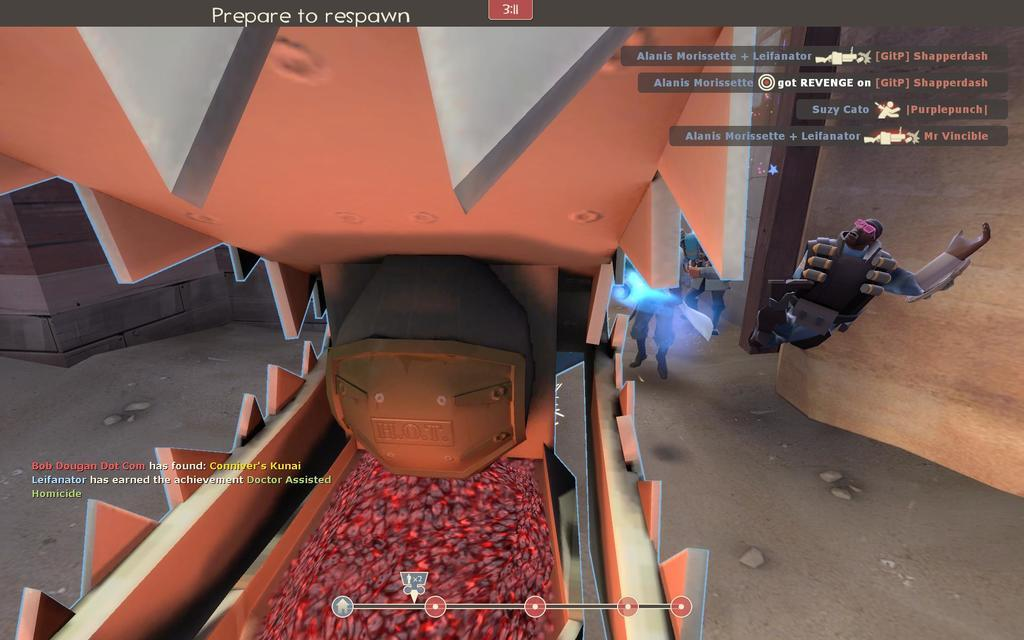What type of image is being described? The image appears to be animated. What is located at the bottom of the image? There is a floor at the bottom of the image. What can be seen to the right of the image? There is text and a wall to the right of the image. What is located to the left of the image? There is text to the left of the image. What type of fruit is being used as a prop in the image? There is no fruit, such as a banana, present in the image. What type of poetry can be seen in the image? The image does not contain any poetry or verses. 